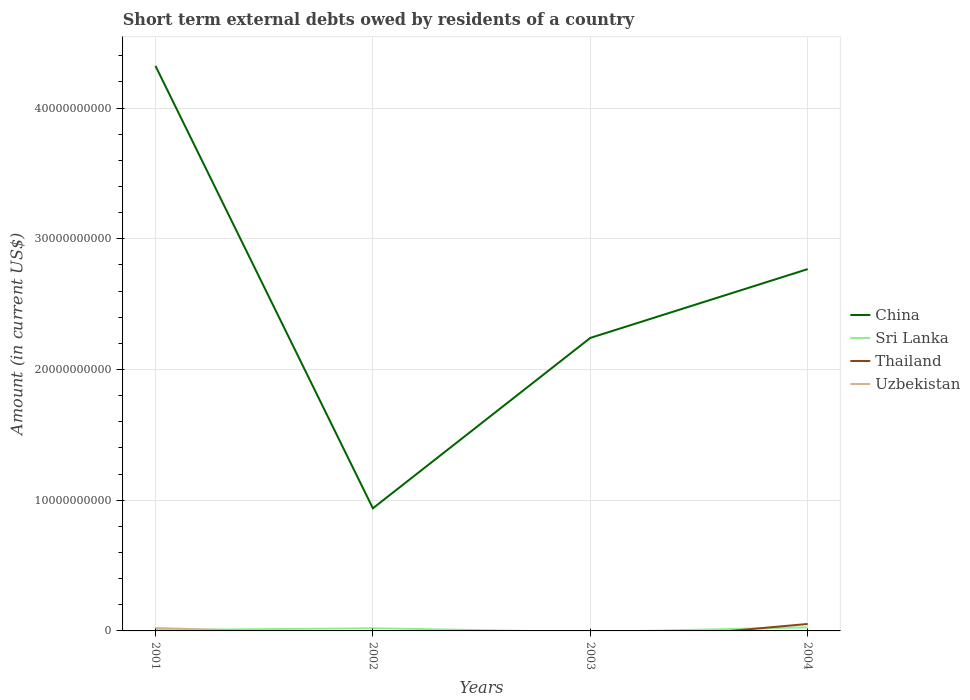How many different coloured lines are there?
Your answer should be very brief. 4. Across all years, what is the maximum amount of short-term external debts owed by residents in Uzbekistan?
Give a very brief answer. 0. What is the total amount of short-term external debts owed by residents in China in the graph?
Provide a succinct answer. -1.83e+1. What is the difference between the highest and the second highest amount of short-term external debts owed by residents in Thailand?
Keep it short and to the point. 5.32e+08. What is the difference between the highest and the lowest amount of short-term external debts owed by residents in Sri Lanka?
Your answer should be very brief. 2. Is the amount of short-term external debts owed by residents in Thailand strictly greater than the amount of short-term external debts owed by residents in Uzbekistan over the years?
Keep it short and to the point. No. How many years are there in the graph?
Your answer should be compact. 4. Are the values on the major ticks of Y-axis written in scientific E-notation?
Give a very brief answer. No. Where does the legend appear in the graph?
Offer a terse response. Center right. How many legend labels are there?
Your answer should be very brief. 4. How are the legend labels stacked?
Provide a succinct answer. Vertical. What is the title of the graph?
Provide a succinct answer. Short term external debts owed by residents of a country. Does "Russian Federation" appear as one of the legend labels in the graph?
Give a very brief answer. No. What is the label or title of the X-axis?
Make the answer very short. Years. What is the label or title of the Y-axis?
Ensure brevity in your answer.  Amount (in current US$). What is the Amount (in current US$) in China in 2001?
Your answer should be compact. 4.32e+1. What is the Amount (in current US$) in Sri Lanka in 2001?
Give a very brief answer. 6.52e+07. What is the Amount (in current US$) in Uzbekistan in 2001?
Your answer should be very brief. 2.21e+08. What is the Amount (in current US$) in China in 2002?
Keep it short and to the point. 9.38e+09. What is the Amount (in current US$) of Sri Lanka in 2002?
Your answer should be compact. 2.07e+08. What is the Amount (in current US$) of Thailand in 2002?
Provide a succinct answer. 0. What is the Amount (in current US$) in China in 2003?
Provide a short and direct response. 2.24e+1. What is the Amount (in current US$) of Thailand in 2003?
Keep it short and to the point. 0. What is the Amount (in current US$) of Uzbekistan in 2003?
Your answer should be compact. 0. What is the Amount (in current US$) of China in 2004?
Make the answer very short. 2.77e+1. What is the Amount (in current US$) in Sri Lanka in 2004?
Offer a very short reply. 2.73e+08. What is the Amount (in current US$) in Thailand in 2004?
Your answer should be very brief. 5.32e+08. What is the Amount (in current US$) of Uzbekistan in 2004?
Your response must be concise. 0. Across all years, what is the maximum Amount (in current US$) of China?
Give a very brief answer. 4.32e+1. Across all years, what is the maximum Amount (in current US$) in Sri Lanka?
Provide a short and direct response. 2.73e+08. Across all years, what is the maximum Amount (in current US$) of Thailand?
Provide a short and direct response. 5.32e+08. Across all years, what is the maximum Amount (in current US$) in Uzbekistan?
Your answer should be compact. 2.21e+08. Across all years, what is the minimum Amount (in current US$) in China?
Your response must be concise. 9.38e+09. Across all years, what is the minimum Amount (in current US$) in Sri Lanka?
Make the answer very short. 0. Across all years, what is the minimum Amount (in current US$) in Uzbekistan?
Give a very brief answer. 0. What is the total Amount (in current US$) of China in the graph?
Offer a very short reply. 1.03e+11. What is the total Amount (in current US$) of Sri Lanka in the graph?
Your answer should be compact. 5.45e+08. What is the total Amount (in current US$) in Thailand in the graph?
Provide a succinct answer. 5.32e+08. What is the total Amount (in current US$) of Uzbekistan in the graph?
Ensure brevity in your answer.  2.21e+08. What is the difference between the Amount (in current US$) in China in 2001 and that in 2002?
Give a very brief answer. 3.38e+1. What is the difference between the Amount (in current US$) in Sri Lanka in 2001 and that in 2002?
Offer a very short reply. -1.41e+08. What is the difference between the Amount (in current US$) of China in 2001 and that in 2003?
Your response must be concise. 2.08e+1. What is the difference between the Amount (in current US$) of China in 2001 and that in 2004?
Provide a succinct answer. 1.55e+1. What is the difference between the Amount (in current US$) in Sri Lanka in 2001 and that in 2004?
Keep it short and to the point. -2.08e+08. What is the difference between the Amount (in current US$) in China in 2002 and that in 2003?
Your answer should be compact. -1.30e+1. What is the difference between the Amount (in current US$) in China in 2002 and that in 2004?
Make the answer very short. -1.83e+1. What is the difference between the Amount (in current US$) in Sri Lanka in 2002 and that in 2004?
Your answer should be compact. -6.63e+07. What is the difference between the Amount (in current US$) in China in 2003 and that in 2004?
Your answer should be very brief. -5.26e+09. What is the difference between the Amount (in current US$) in China in 2001 and the Amount (in current US$) in Sri Lanka in 2002?
Offer a very short reply. 4.30e+1. What is the difference between the Amount (in current US$) in China in 2001 and the Amount (in current US$) in Sri Lanka in 2004?
Ensure brevity in your answer.  4.29e+1. What is the difference between the Amount (in current US$) of China in 2001 and the Amount (in current US$) of Thailand in 2004?
Your answer should be very brief. 4.27e+1. What is the difference between the Amount (in current US$) of Sri Lanka in 2001 and the Amount (in current US$) of Thailand in 2004?
Your response must be concise. -4.67e+08. What is the difference between the Amount (in current US$) of China in 2002 and the Amount (in current US$) of Sri Lanka in 2004?
Provide a short and direct response. 9.11e+09. What is the difference between the Amount (in current US$) in China in 2002 and the Amount (in current US$) in Thailand in 2004?
Ensure brevity in your answer.  8.85e+09. What is the difference between the Amount (in current US$) of Sri Lanka in 2002 and the Amount (in current US$) of Thailand in 2004?
Offer a very short reply. -3.25e+08. What is the difference between the Amount (in current US$) of China in 2003 and the Amount (in current US$) of Sri Lanka in 2004?
Give a very brief answer. 2.21e+1. What is the difference between the Amount (in current US$) in China in 2003 and the Amount (in current US$) in Thailand in 2004?
Make the answer very short. 2.19e+1. What is the average Amount (in current US$) in China per year?
Your answer should be very brief. 2.57e+1. What is the average Amount (in current US$) of Sri Lanka per year?
Give a very brief answer. 1.36e+08. What is the average Amount (in current US$) of Thailand per year?
Your answer should be compact. 1.33e+08. What is the average Amount (in current US$) of Uzbekistan per year?
Ensure brevity in your answer.  5.51e+07. In the year 2001, what is the difference between the Amount (in current US$) of China and Amount (in current US$) of Sri Lanka?
Provide a succinct answer. 4.32e+1. In the year 2001, what is the difference between the Amount (in current US$) of China and Amount (in current US$) of Uzbekistan?
Your answer should be compact. 4.30e+1. In the year 2001, what is the difference between the Amount (in current US$) of Sri Lanka and Amount (in current US$) of Uzbekistan?
Provide a succinct answer. -1.55e+08. In the year 2002, what is the difference between the Amount (in current US$) in China and Amount (in current US$) in Sri Lanka?
Provide a short and direct response. 9.17e+09. In the year 2004, what is the difference between the Amount (in current US$) in China and Amount (in current US$) in Sri Lanka?
Make the answer very short. 2.74e+1. In the year 2004, what is the difference between the Amount (in current US$) of China and Amount (in current US$) of Thailand?
Provide a succinct answer. 2.71e+1. In the year 2004, what is the difference between the Amount (in current US$) in Sri Lanka and Amount (in current US$) in Thailand?
Give a very brief answer. -2.59e+08. What is the ratio of the Amount (in current US$) of China in 2001 to that in 2002?
Give a very brief answer. 4.61. What is the ratio of the Amount (in current US$) of Sri Lanka in 2001 to that in 2002?
Provide a short and direct response. 0.32. What is the ratio of the Amount (in current US$) of China in 2001 to that in 2003?
Your answer should be very brief. 1.93. What is the ratio of the Amount (in current US$) in China in 2001 to that in 2004?
Keep it short and to the point. 1.56. What is the ratio of the Amount (in current US$) in Sri Lanka in 2001 to that in 2004?
Offer a very short reply. 0.24. What is the ratio of the Amount (in current US$) in China in 2002 to that in 2003?
Your response must be concise. 0.42. What is the ratio of the Amount (in current US$) of China in 2002 to that in 2004?
Your answer should be compact. 0.34. What is the ratio of the Amount (in current US$) in Sri Lanka in 2002 to that in 2004?
Give a very brief answer. 0.76. What is the ratio of the Amount (in current US$) of China in 2003 to that in 2004?
Keep it short and to the point. 0.81. What is the difference between the highest and the second highest Amount (in current US$) in China?
Give a very brief answer. 1.55e+1. What is the difference between the highest and the second highest Amount (in current US$) in Sri Lanka?
Your answer should be compact. 6.63e+07. What is the difference between the highest and the lowest Amount (in current US$) in China?
Your answer should be compact. 3.38e+1. What is the difference between the highest and the lowest Amount (in current US$) in Sri Lanka?
Your answer should be very brief. 2.73e+08. What is the difference between the highest and the lowest Amount (in current US$) in Thailand?
Your response must be concise. 5.32e+08. What is the difference between the highest and the lowest Amount (in current US$) in Uzbekistan?
Provide a succinct answer. 2.21e+08. 